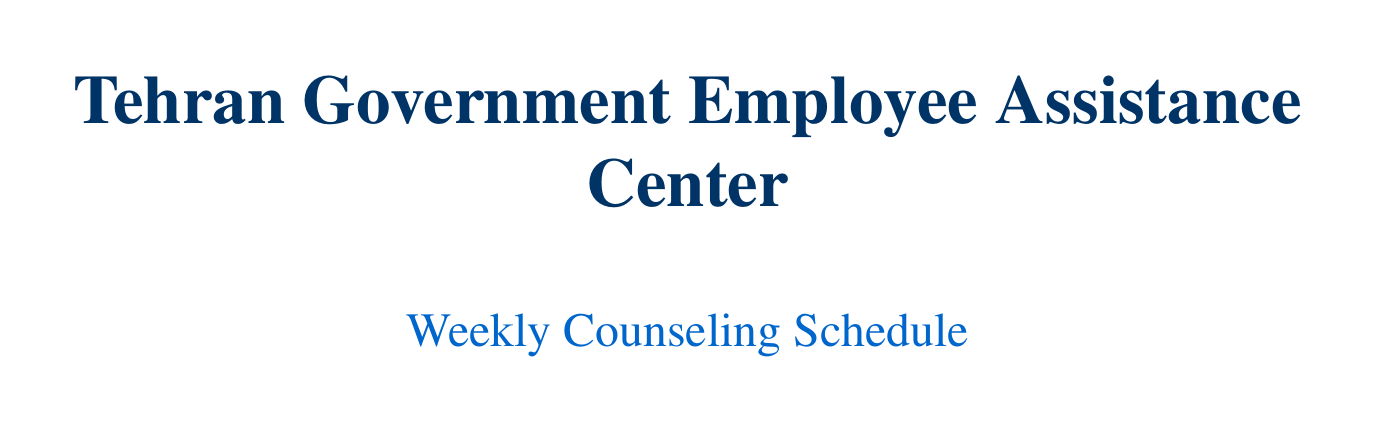what is the location of the Wellness Library? The Wellness Library is located on the 2nd Floor of the Tehran Government Employee Assistance Center.
Answer: 2nd Floor, Tehran Government Employee Assistance Center who is the counselor for Stress Management for Public Servants? The counselor for Stress Management for Public Servants is Dr. Amir Hosseini.
Answer: Dr. Amir Hosseini what time does the session on Dealing with Burnout in Public Service start? The session on Dealing with Burnout in Public Service starts at 13:00.
Answer: 13:00 how many sessions are held on Wednesday? There are three sessions held on Wednesday, as listed in the schedule.
Answer: 3 which room is used for Improving Communication Skills in Public Administration? The room used for Improving Communication Skills in Public Administration is the Saadi Seminar Room.
Answer: Saadi Seminar Room what topic is covered during the session held in Ghazali Auditorium? The topic covered during the session in Ghazali Auditorium is Building Resilience in Challenging Work Environments.
Answer: Building Resilience in Challenging Work Environments what is the contact number for the Employee Assistance Program Hotline? The contact number for the Employee Assistance Program Hotline is provided in the additional resources section.
Answer: +98 21 1234 5678 on which day does the session on Ethical Decision Making in Public Service take place? The session on Ethical Decision Making in Public Service takes place on Wednesday.
Answer: Wednesday 